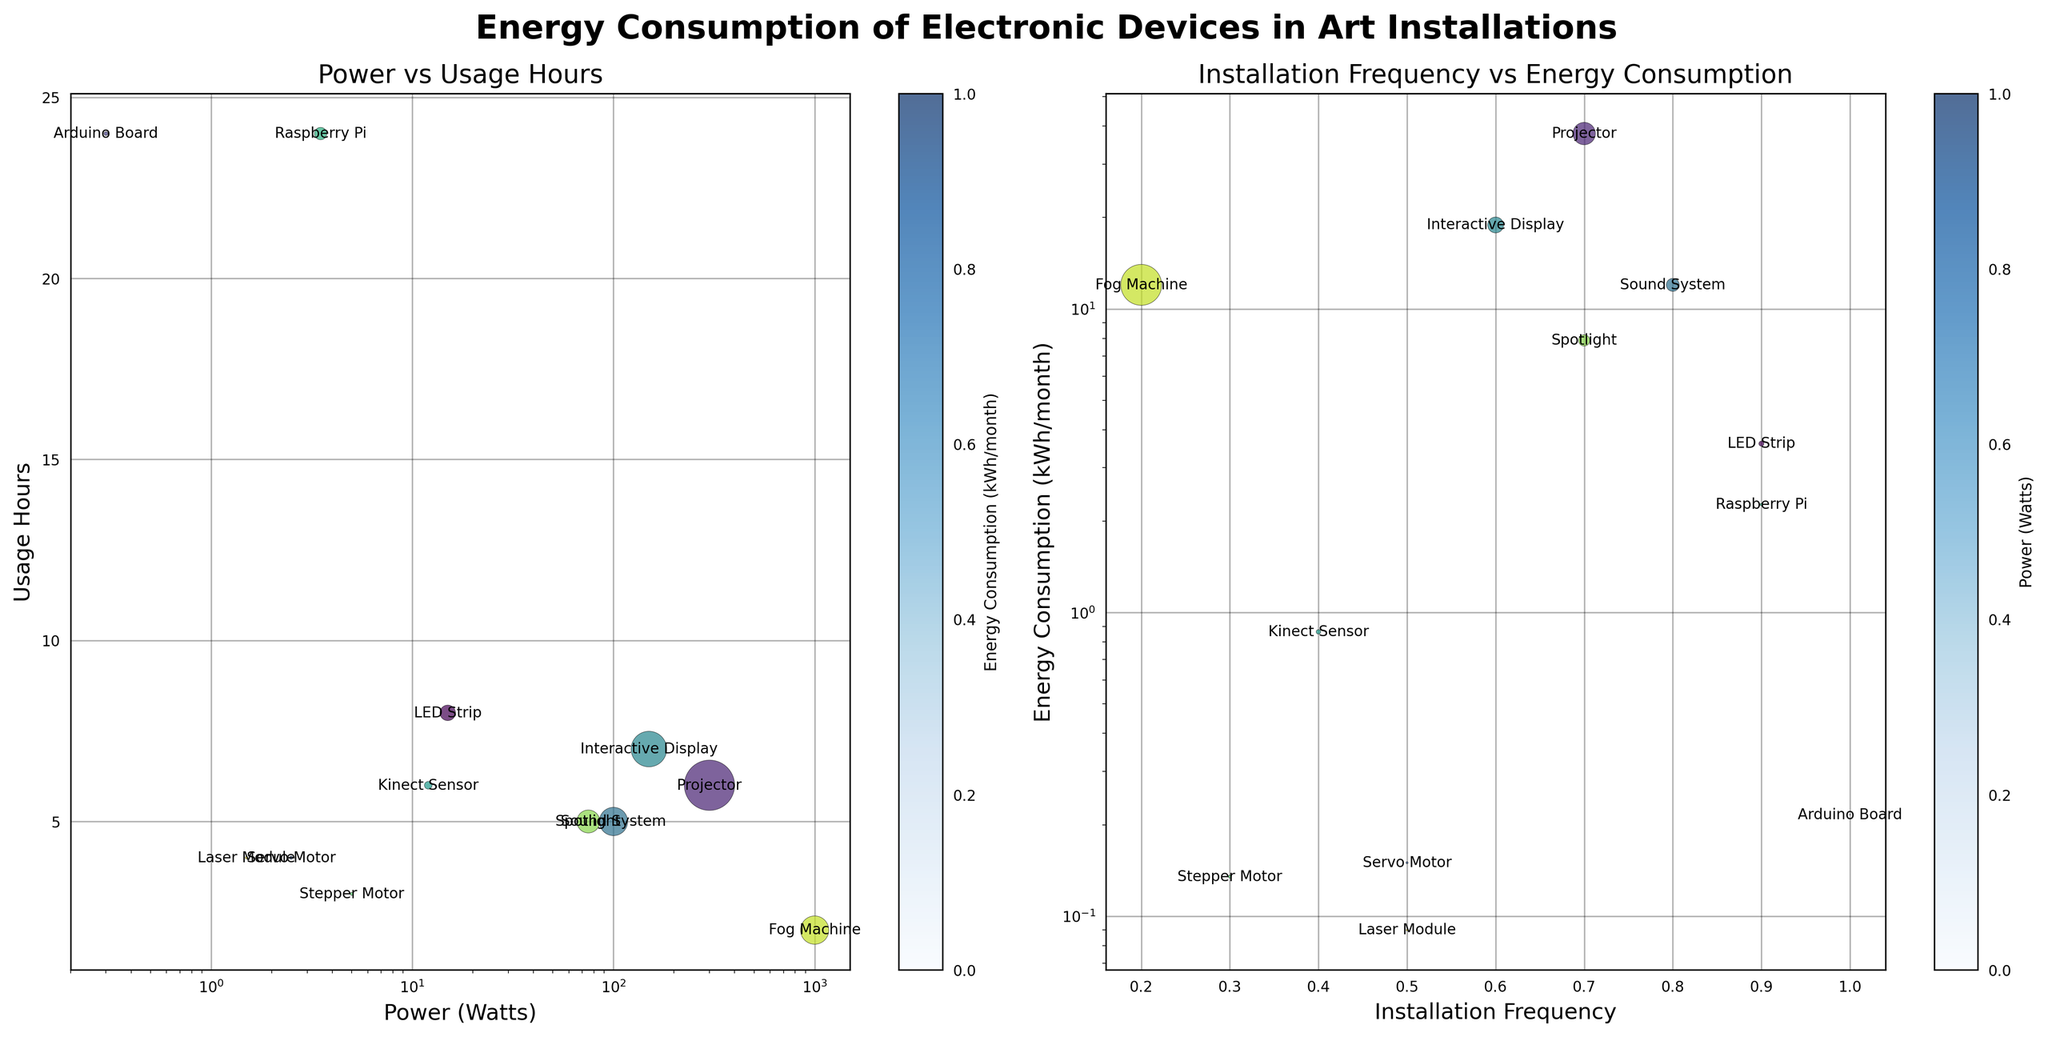What is the title of the left subplot? The title of the left subplot is located at the top of the first subplot. It reads "Power vs Usage Hours" as labeled in the figure.
Answer: Power vs Usage Hours What is the power consumption in watts of the projector? To find the power consumption of the projector, locate the corresponding data point in the first subplot. The scatter plot shows the projector with a higher value on the x-axis for power consumption, which is labeled as 300 Watts.
Answer: 300 Watts Based on the right subplot, which device has the highest energy consumption per month? Locate the highest point on the y-axis in the right subplot labeled "Energy Consumption (kWh/month)." The projector is positioned at the highest value, indicating it has the highest energy consumption per month of 37.8 kWh.
Answer: Projector Which device operates for 24 hours daily? Look at the left subplot on the y-axis labeled "Usage Hours." Identify the data points located at 24 hours. Both the Arduino Board and Raspberry Pi are found at this position.
Answer: Arduino Board, Raspberry Pi Compare the energy consumption per month between the LED Strip and Sound System. Which one is higher? In the right subplot, find the data points corresponding to the LED Strip and Sound System on both axes. The LED Strip's energy consumption is 3.6 kWh/month, while the Sound System's energy consumption is 12 kWh/month, indicating the Sound System has higher energy consumption.
Answer: Sound System What's the average installation frequency for Servo Motor and Laser Module? Locate the installation frequencies of the Servo Motor and Laser Module in the right subplot. Their frequencies are 0.5 and 0.5, respectively. The average is calculated as (0.5 + 0.5) / 2 = 0.5.
Answer: 0.5 Which device uses the least power? The left subplot on the x-axis represents power in watts. The device with the smallest position on this axis is the Arduino Board at 0.3 Watts.
Answer: Arduino Board How many devices have an installation frequency of 0.5? In the right subplot, identify the points that align with the x-axis value of 0.5. The devices with this frequency are Servo Motor and Laser Module.
Answer: 2 What’s the total energy consumption per month for devices with a power rating of 100 watts? Referring to the left subplot and the data, the devices with 100 watts are the Sound System and Fog Machine. Their energy consumption values are 12 kWh/month each. The total is 12 + 12 = 24 kWh/month.
Answer: 24 kWh/month On the left subplot, which device has the highest usage hours among those with a power rating below 10 watts? Identify the points below 10 watts on the x-axis of the left subplot. Check the corresponding usage hours. The Raspberry Pi is used for 24 hours daily, which is the highest among those below 10 watts.
Answer: Raspberry Pi 